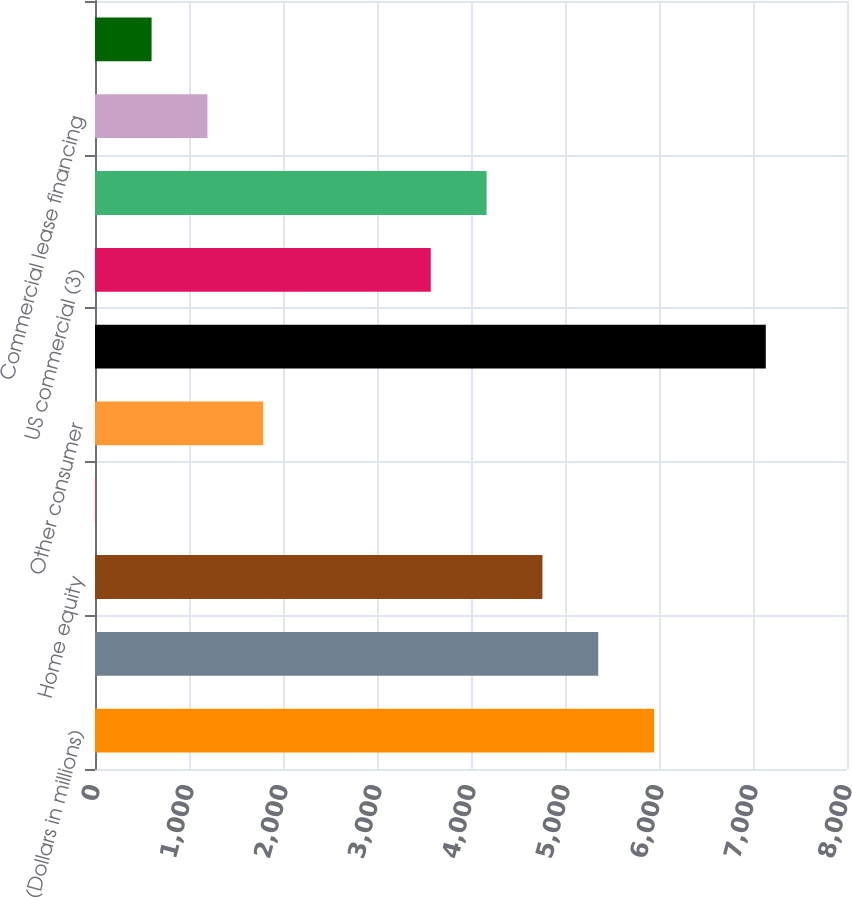Convert chart. <chart><loc_0><loc_0><loc_500><loc_500><bar_chart><fcel>(Dollars in millions)<fcel>Residential mortgage<fcel>Home equity<fcel>Direct/Indirect consumer<fcel>Other consumer<fcel>Total consumer (2)<fcel>US commercial (3)<fcel>Commercial real estate<fcel>Commercial lease financing<fcel>Non-US commercial<nl><fcel>5948<fcel>5354<fcel>4760<fcel>8<fcel>1790<fcel>7136<fcel>3572<fcel>4166<fcel>1196<fcel>602<nl></chart> 